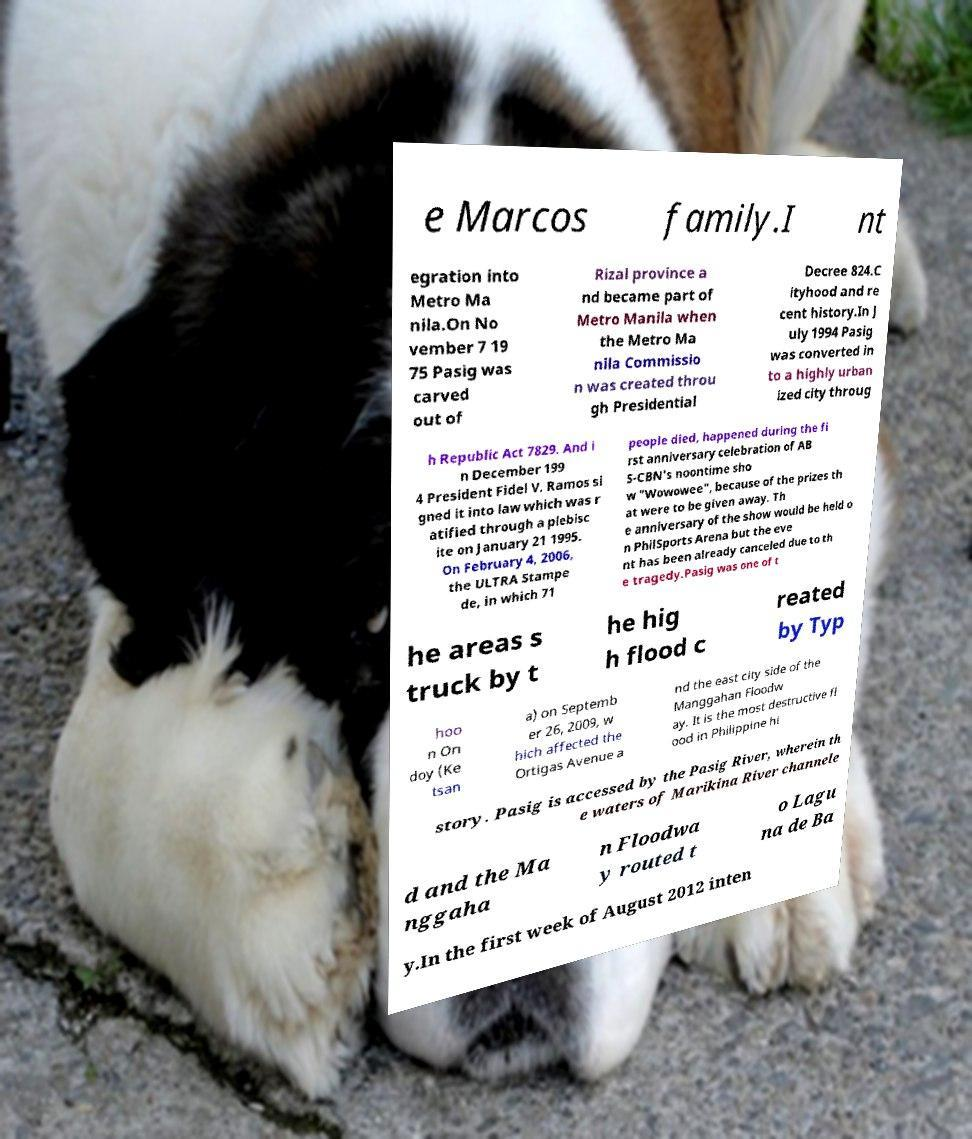Can you read and provide the text displayed in the image?This photo seems to have some interesting text. Can you extract and type it out for me? e Marcos family.I nt egration into Metro Ma nila.On No vember 7 19 75 Pasig was carved out of Rizal province a nd became part of Metro Manila when the Metro Ma nila Commissio n was created throu gh Presidential Decree 824.C ityhood and re cent history.In J uly 1994 Pasig was converted in to a highly urban ized city throug h Republic Act 7829. And i n December 199 4 President Fidel V. Ramos si gned it into law which was r atified through a plebisc ite on January 21 1995. On February 4, 2006, the ULTRA Stampe de, in which 71 people died, happened during the fi rst anniversary celebration of AB S-CBN's noontime sho w "Wowowee", because of the prizes th at were to be given away. Th e anniversary of the show would be held o n PhilSports Arena but the eve nt has been already canceled due to th e tragedy.Pasig was one of t he areas s truck by t he hig h flood c reated by Typ hoo n On doy (Ke tsan a) on Septemb er 26, 2009, w hich affected the Ortigas Avenue a nd the east city side of the Manggahan Floodw ay. It is the most destructive fl ood in Philippine hi story. Pasig is accessed by the Pasig River, wherein th e waters of Marikina River channele d and the Ma nggaha n Floodwa y routed t o Lagu na de Ba y.In the first week of August 2012 inten 